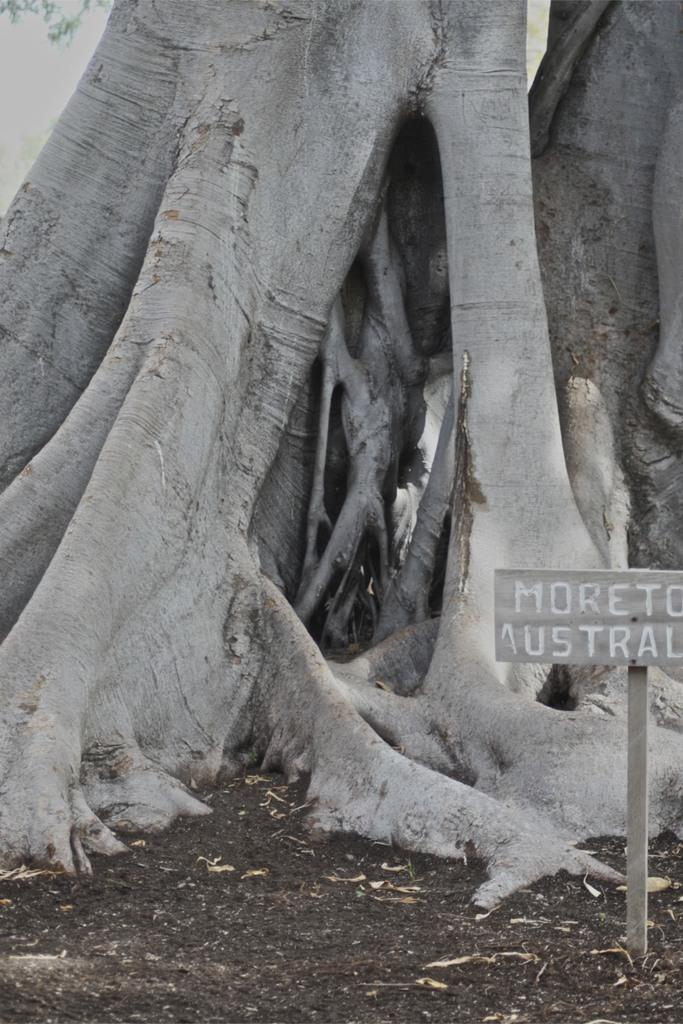What type of plant can be seen in the image? There is a tree in the image. What object is located on the right side of the image? There is a board on the right side of the image. What is written or depicted on the board? There is text on the board. What is present at the bottom of the image? Leaves and soil are visible at the bottom of the image. What type of behavior can be observed in the tree in the image? There is no behavior to observe in the tree, as it is a static object in the image. Who is the creator of the tree in the image? The tree is a natural object and not created by a specific person, so it does not have a creator. 